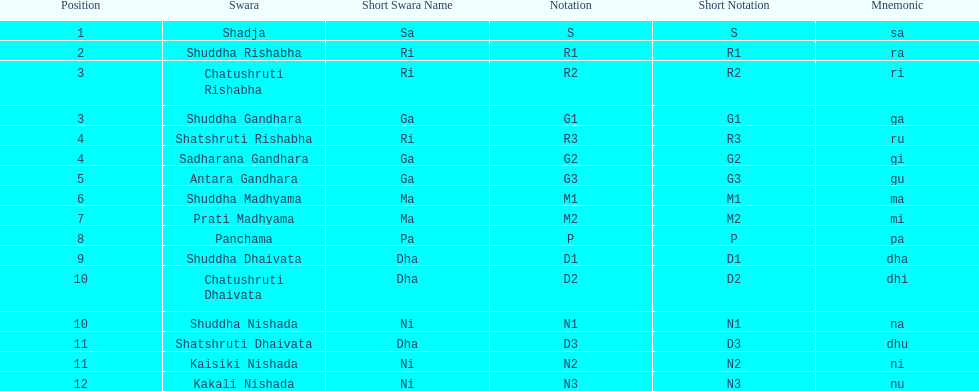Would you mind parsing the complete table? {'header': ['Position', 'Swara', 'Short Swara Name', 'Notation', 'Short Notation', 'Mnemonic'], 'rows': [['1', 'Shadja', 'Sa', 'S', 'S', 'sa'], ['2', 'Shuddha Rishabha', 'Ri', 'R1', 'R1', 'ra'], ['3', 'Chatushruti Rishabha', 'Ri', 'R2', 'R2', 'ri'], ['3', 'Shuddha Gandhara', 'Ga', 'G1', 'G1', 'ga'], ['4', 'Shatshruti Rishabha', 'Ri', 'R3', 'R3', 'ru'], ['4', 'Sadharana Gandhara', 'Ga', 'G2', 'G2', 'gi'], ['5', 'Antara Gandhara', 'Ga', 'G3', 'G3', 'gu'], ['6', 'Shuddha Madhyama', 'Ma', 'M1', 'M1', 'ma'], ['7', 'Prati Madhyama', 'Ma', 'M2', 'M2', 'mi'], ['8', 'Panchama', 'Pa', 'P', 'P', 'pa'], ['9', 'Shuddha Dhaivata', 'Dha', 'D1', 'D1', 'dha'], ['10', 'Chatushruti Dhaivata', 'Dha', 'D2', 'D2', 'dhi'], ['10', 'Shuddha Nishada', 'Ni', 'N1', 'N1', 'na'], ['11', 'Shatshruti Dhaivata', 'Dha', 'D3', 'D3', 'dhu'], ['11', 'Kaisiki Nishada', 'Ni', 'N2', 'N2', 'ni'], ['12', 'Kakali Nishada', 'Ni', 'N3', 'N3', 'nu']]} How many swaras do not have dhaivata in their name? 13. 